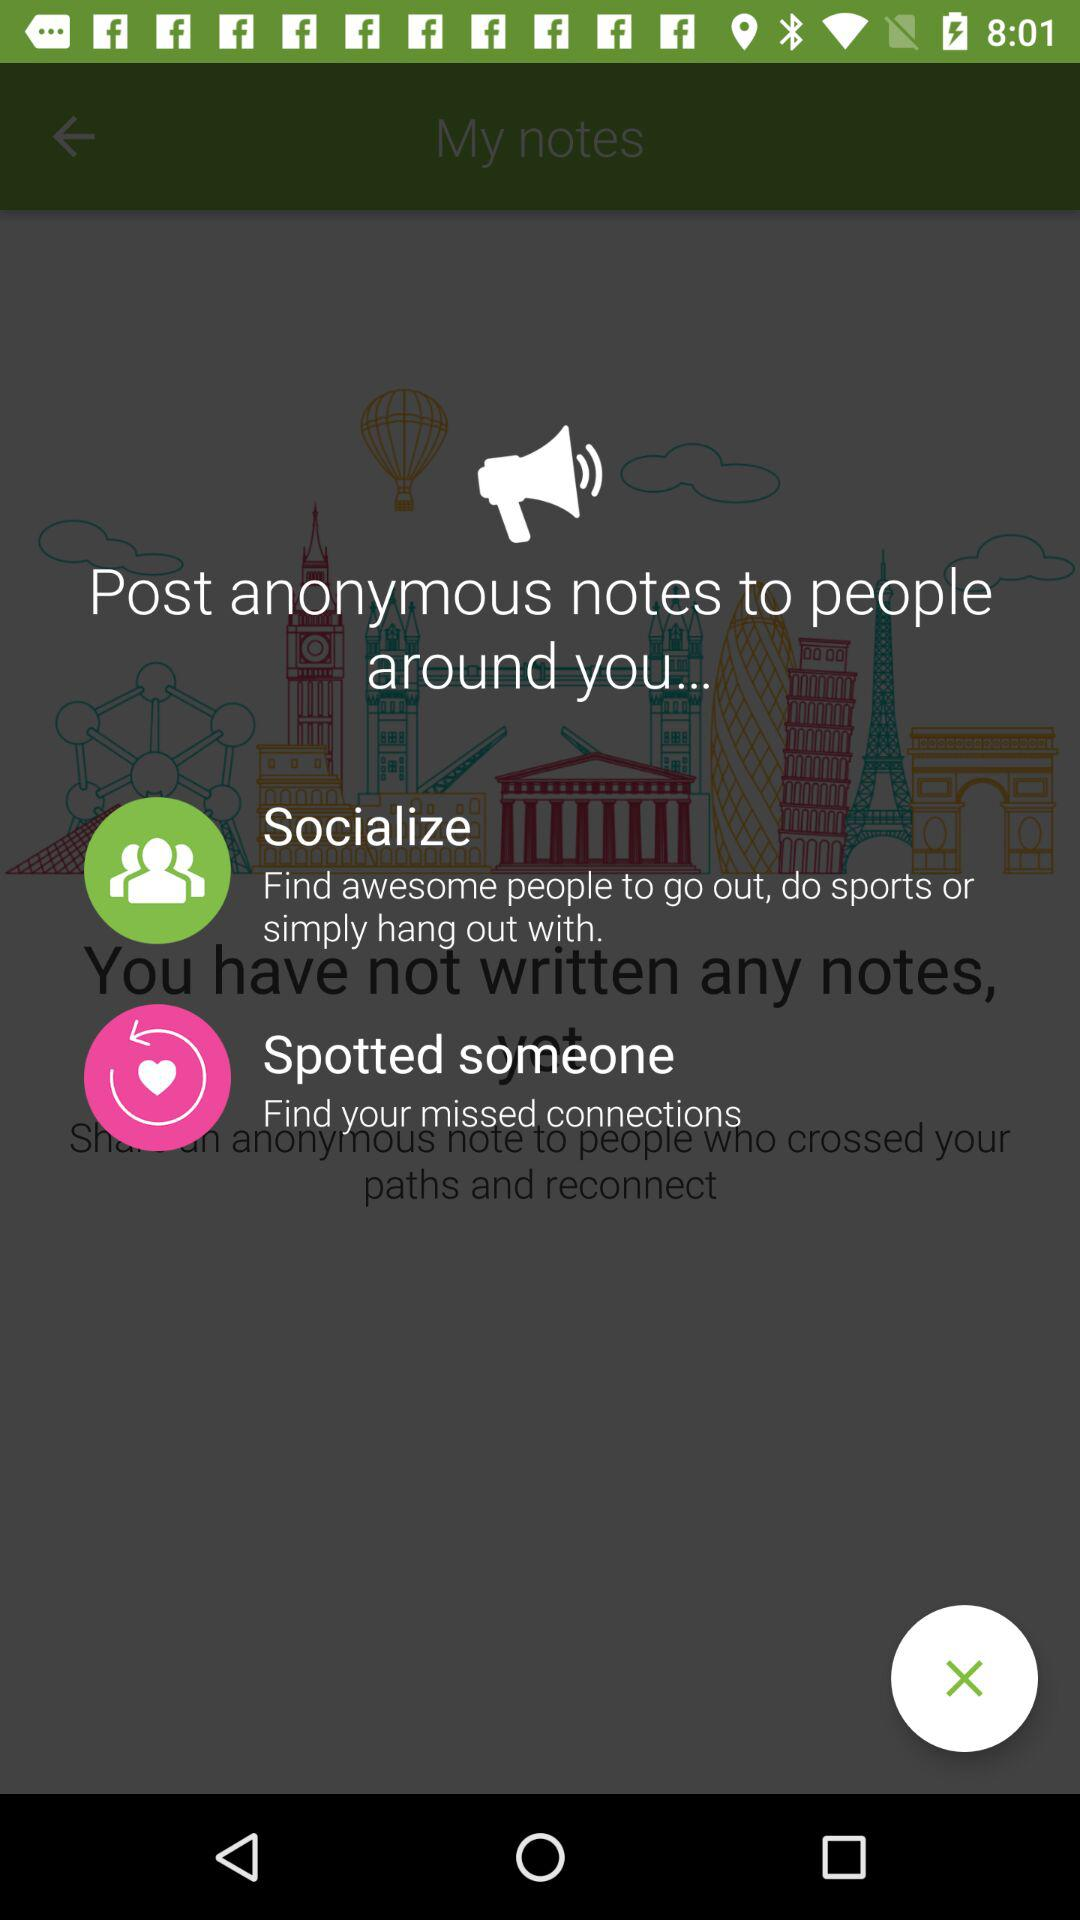How to find missed connections?
When the provided information is insufficient, respond with <no answer>. <no answer> 